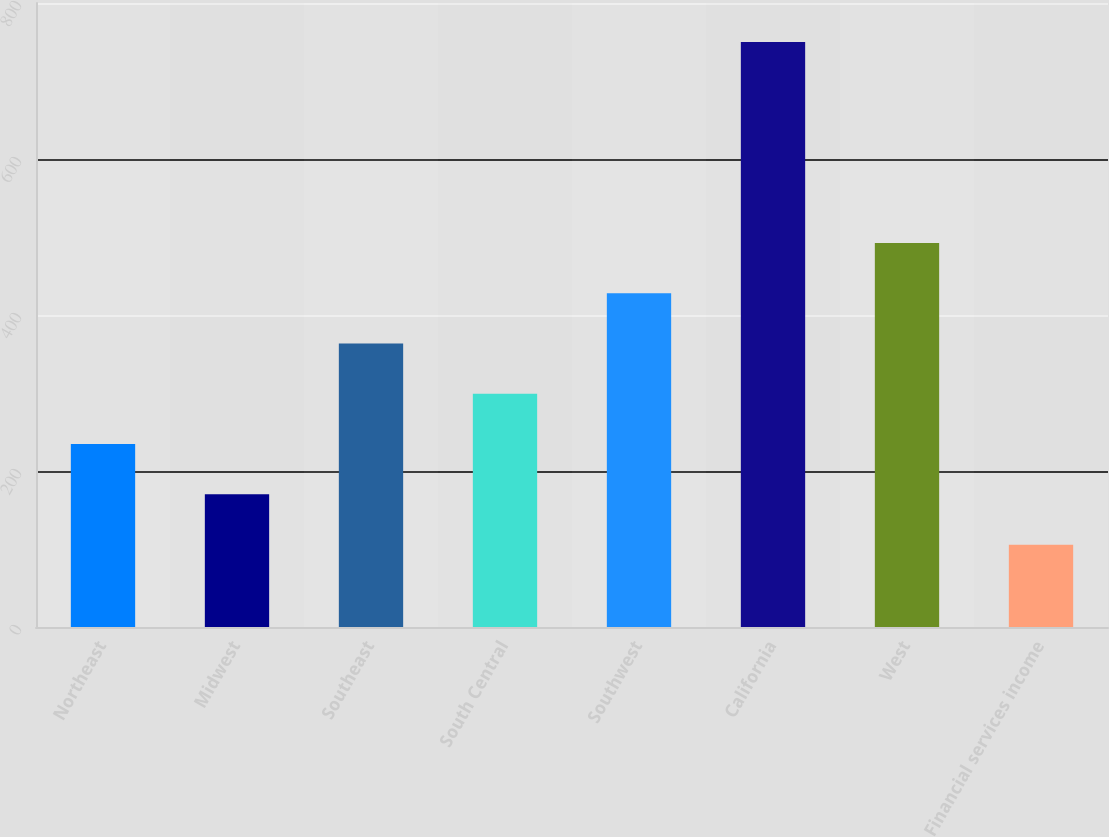Convert chart. <chart><loc_0><loc_0><loc_500><loc_500><bar_chart><fcel>Northeast<fcel>Midwest<fcel>Southeast<fcel>South Central<fcel>Southwest<fcel>California<fcel>West<fcel>Financial services income<nl><fcel>234.5<fcel>170.05<fcel>363.4<fcel>298.95<fcel>427.85<fcel>750.1<fcel>492.3<fcel>105.6<nl></chart> 